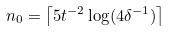Convert formula to latex. <formula><loc_0><loc_0><loc_500><loc_500>n _ { 0 } = \left \lceil 5 t ^ { - 2 } \log ( 4 \delta ^ { - 1 } ) \right \rceil</formula> 